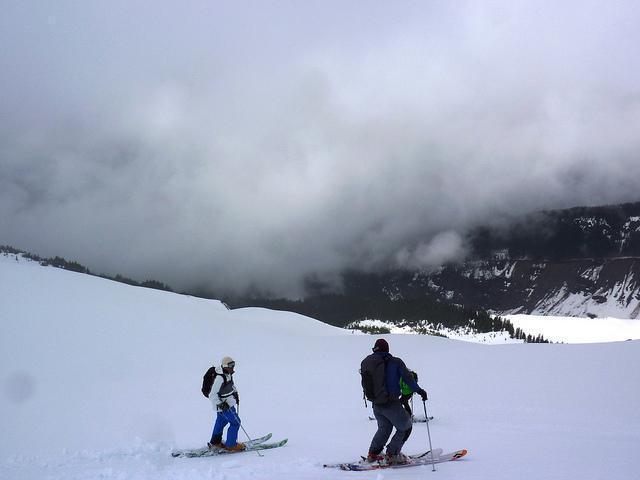How many people are in this picture?
Give a very brief answer. 3. How many people are in the picture?
Give a very brief answer. 2. 